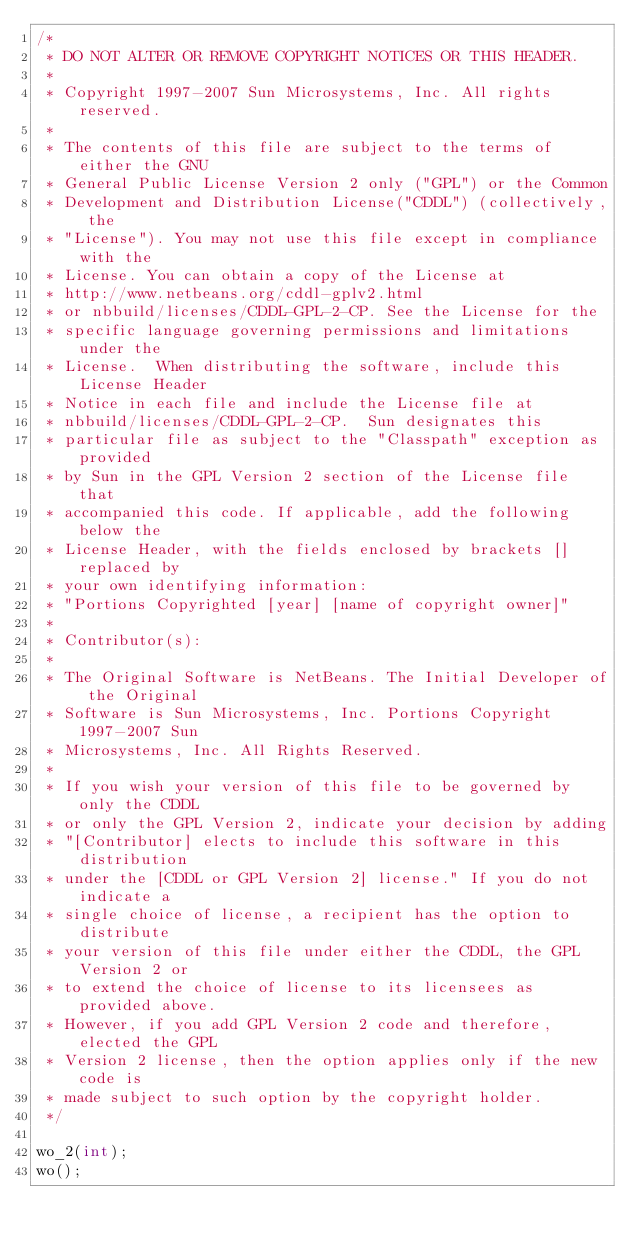<code> <loc_0><loc_0><loc_500><loc_500><_C++_>/*
 * DO NOT ALTER OR REMOVE COPYRIGHT NOTICES OR THIS HEADER.
 *
 * Copyright 1997-2007 Sun Microsystems, Inc. All rights reserved.
 *
 * The contents of this file are subject to the terms of either the GNU
 * General Public License Version 2 only ("GPL") or the Common
 * Development and Distribution License("CDDL") (collectively, the
 * "License"). You may not use this file except in compliance with the
 * License. You can obtain a copy of the License at
 * http://www.netbeans.org/cddl-gplv2.html
 * or nbbuild/licenses/CDDL-GPL-2-CP. See the License for the
 * specific language governing permissions and limitations under the
 * License.  When distributing the software, include this License Header
 * Notice in each file and include the License file at
 * nbbuild/licenses/CDDL-GPL-2-CP.  Sun designates this
 * particular file as subject to the "Classpath" exception as provided
 * by Sun in the GPL Version 2 section of the License file that
 * accompanied this code. If applicable, add the following below the
 * License Header, with the fields enclosed by brackets [] replaced by
 * your own identifying information:
 * "Portions Copyrighted [year] [name of copyright owner]"
 *
 * Contributor(s):
 *
 * The Original Software is NetBeans. The Initial Developer of the Original
 * Software is Sun Microsystems, Inc. Portions Copyright 1997-2007 Sun
 * Microsystems, Inc. All Rights Reserved.
 *
 * If you wish your version of this file to be governed by only the CDDL
 * or only the GPL Version 2, indicate your decision by adding
 * "[Contributor] elects to include this software in this distribution
 * under the [CDDL or GPL Version 2] license." If you do not indicate a
 * single choice of license, a recipient has the option to distribute
 * your version of this file under either the CDDL, the GPL Version 2 or
 * to extend the choice of license to its licensees as provided above.
 * However, if you add GPL Version 2 code and therefore, elected the GPL
 * Version 2 license, then the option applies only if the new code is
 * made subject to such option by the copyright holder.
 */

wo_2(int);
wo();
</code> 